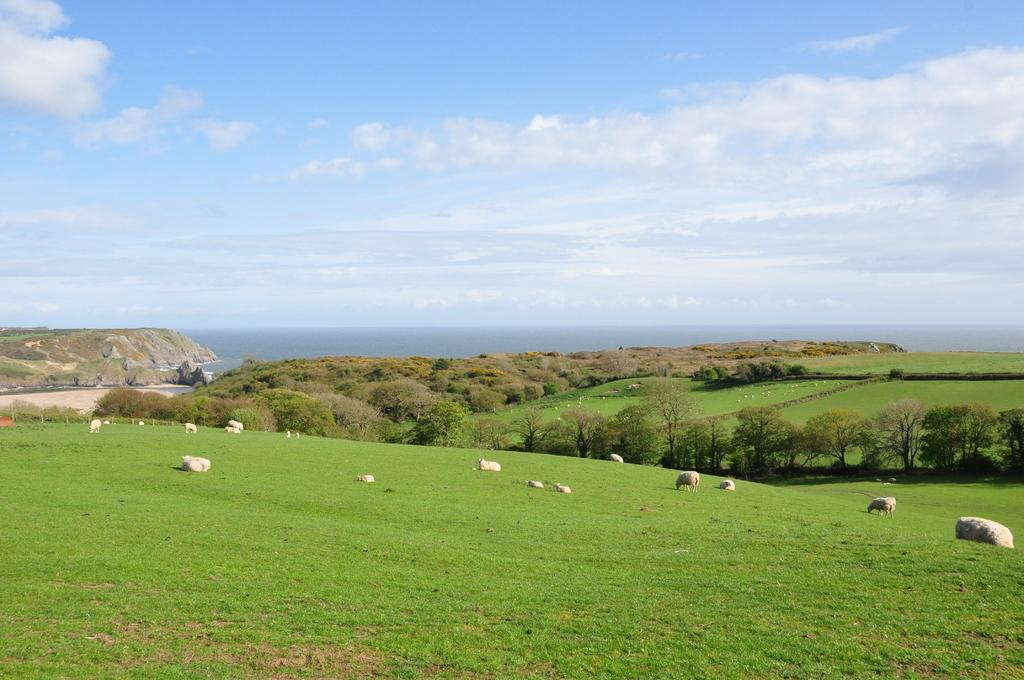What animals can be seen in the middle of the image? Sheep are grazing in the middle of the image. What are the sheep doing in the image? The sheep are grazing on grass. What type of vegetation is present in the image? There are trees in the image. What natural feature can be seen at the back side of the image? The sea is visible at the back side of the image. How would you describe the weather in the image? The sky is cloudy in the image. What musical instrument is being played by the sheep in the image? There is no musical instrument being played by the sheep in the image; they are grazing on grass. 